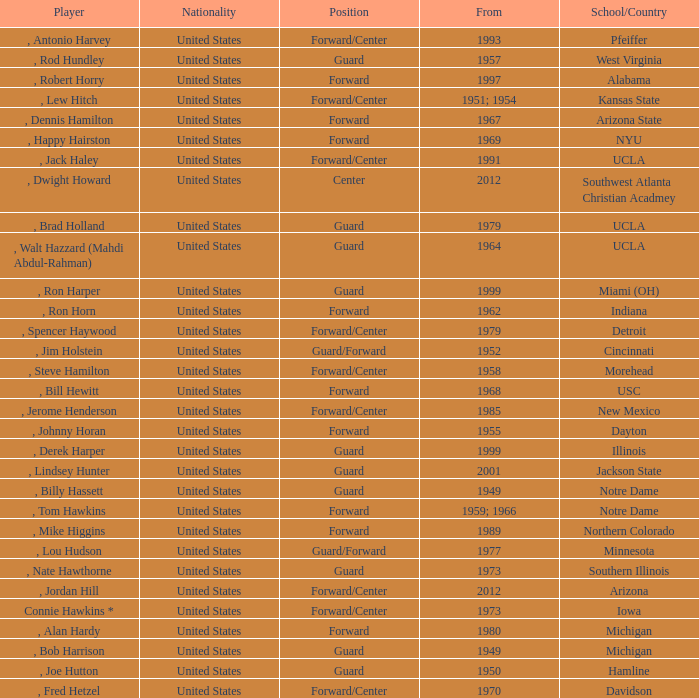What position was for Arizona State? Forward. 